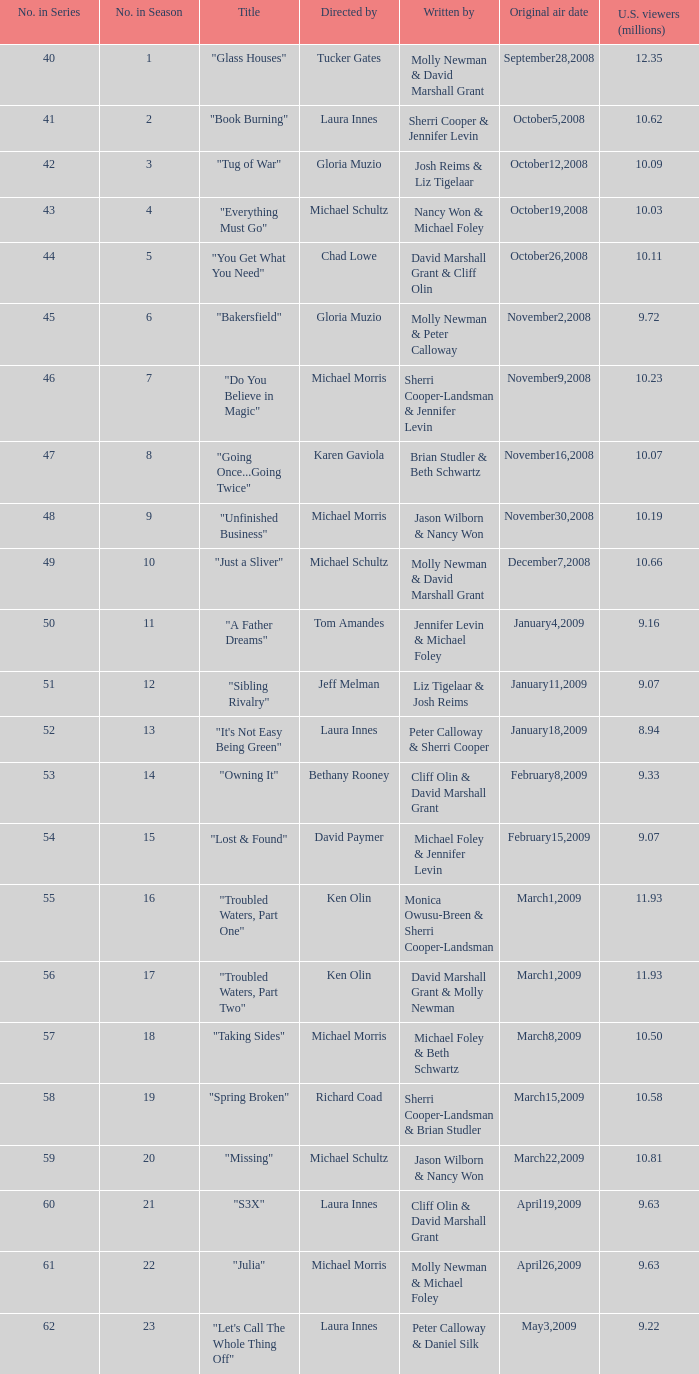50 million individuals in the us initially aired? March8,2009. 